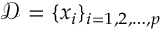Convert formula to latex. <formula><loc_0><loc_0><loc_500><loc_500>\mathcal { D } = \{ x _ { i } \} _ { i = 1 , 2 , \dots , p }</formula> 